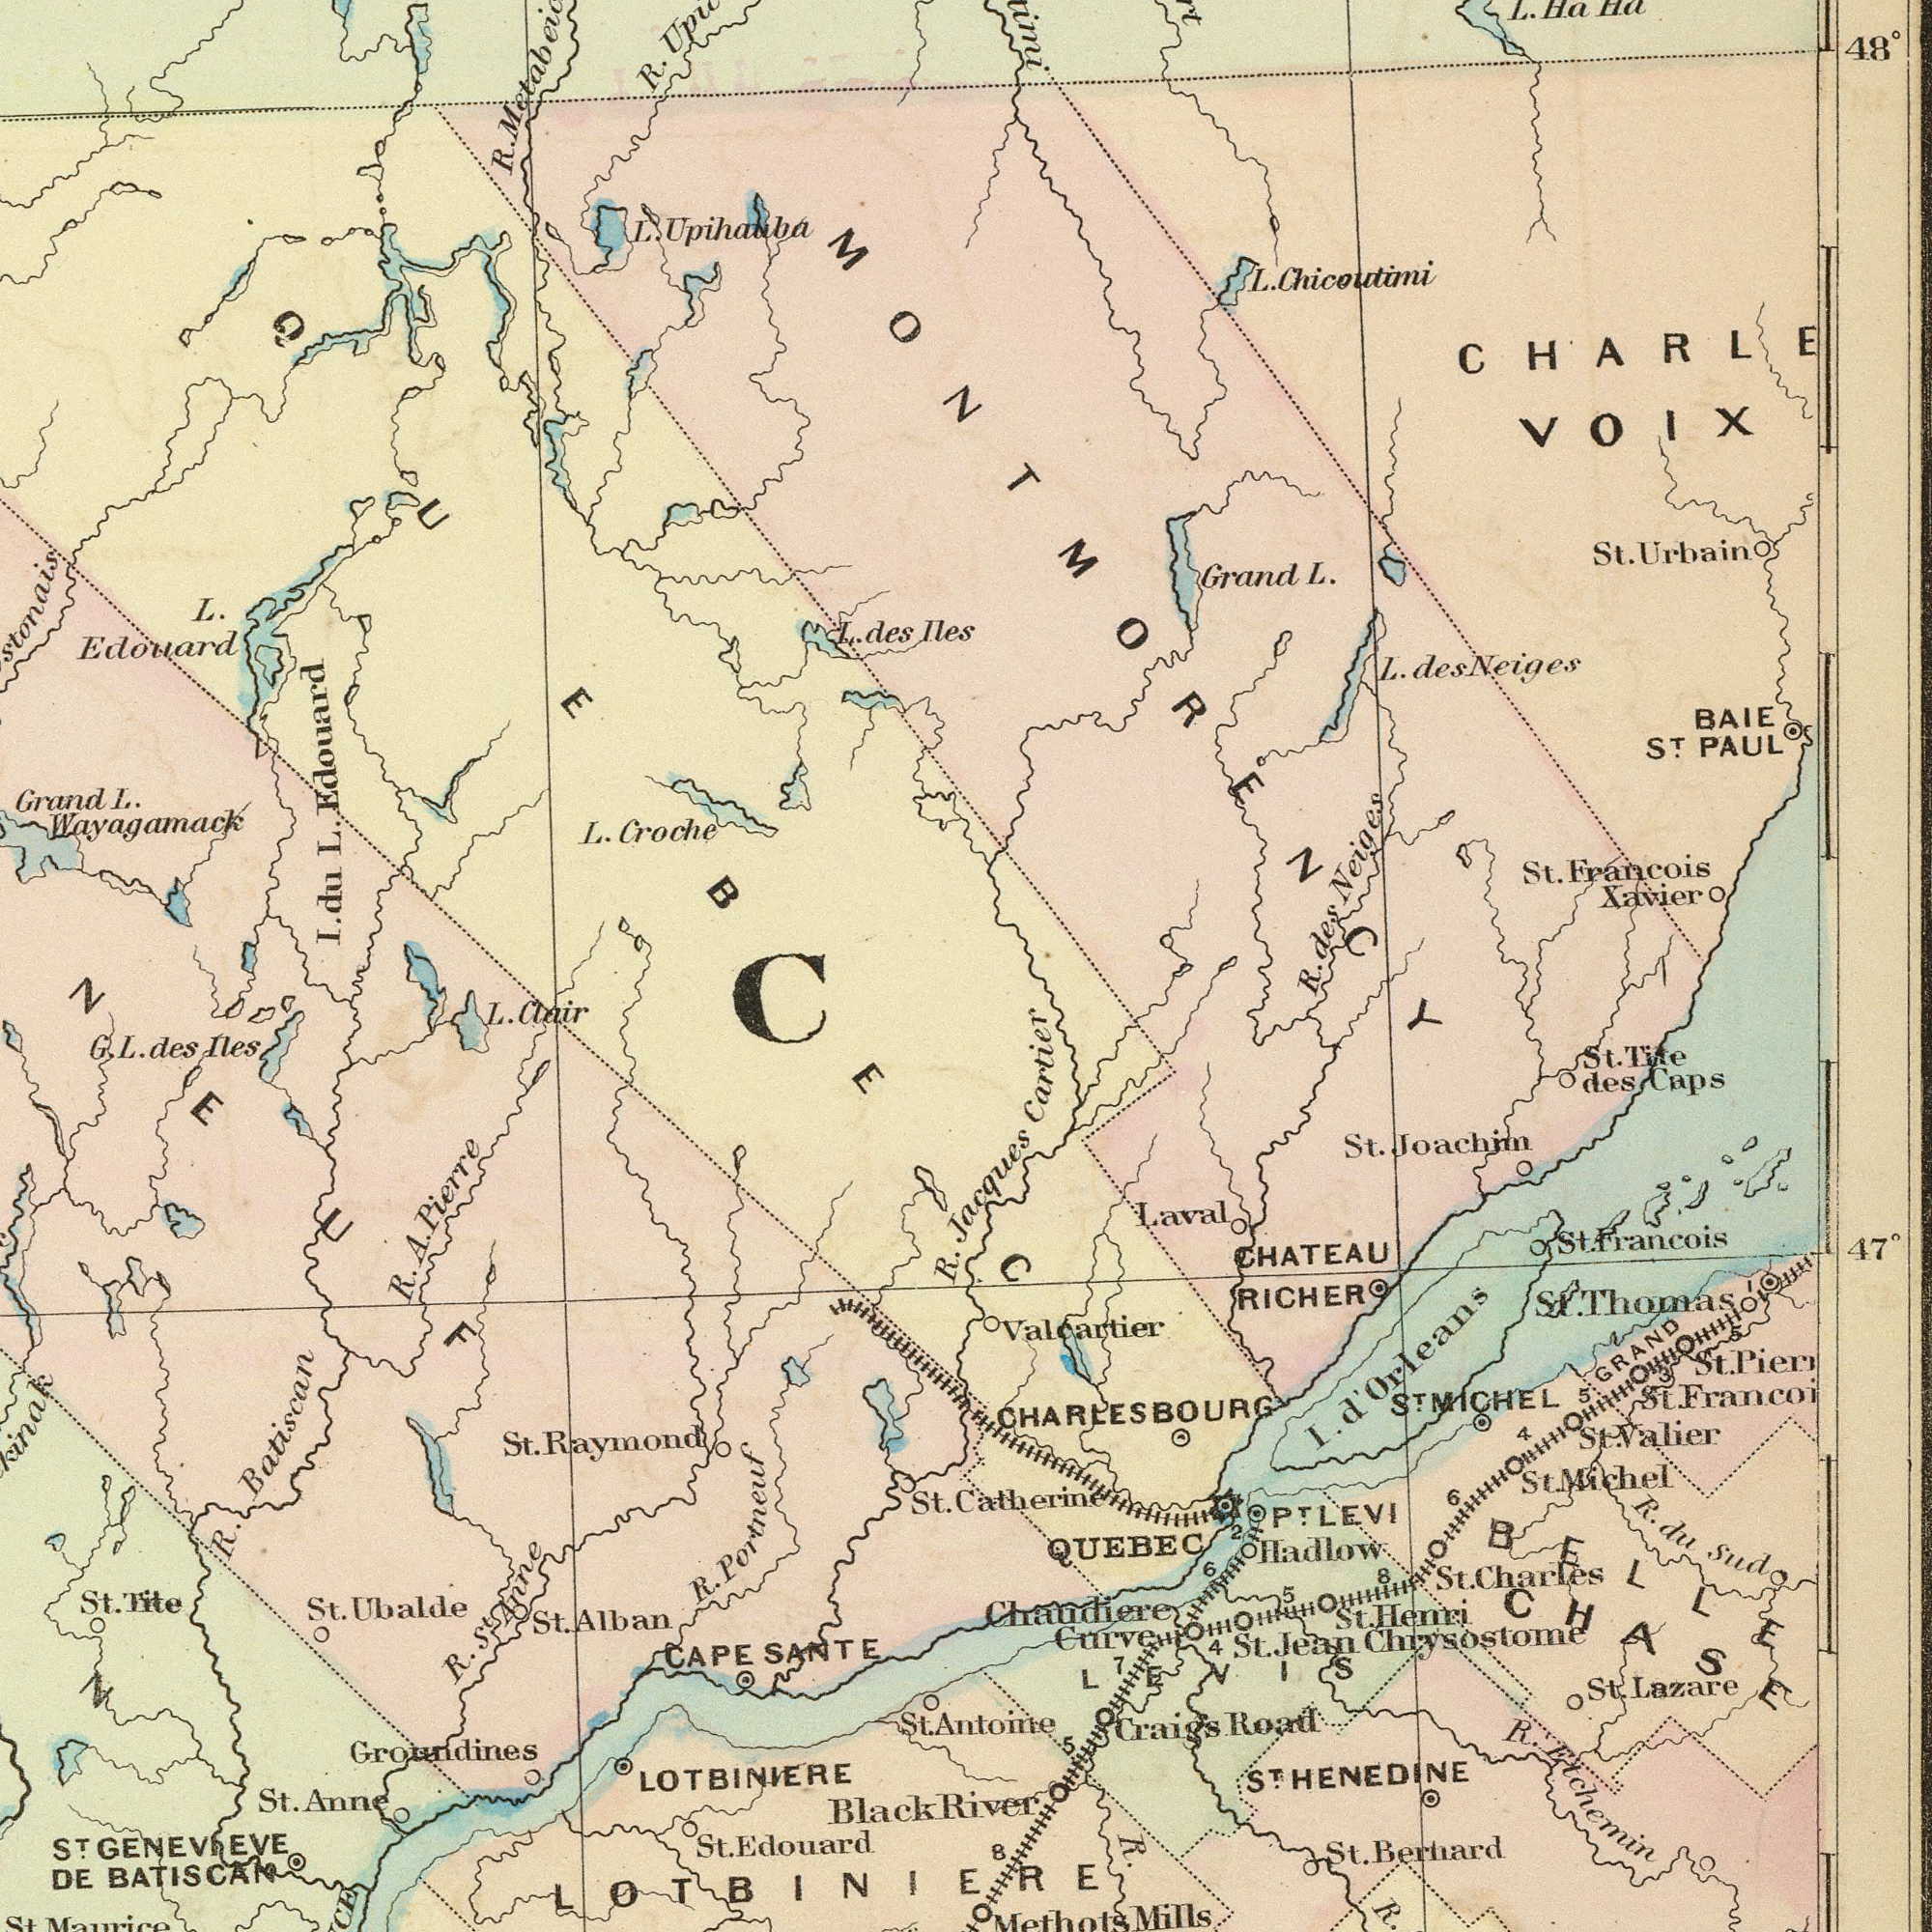What text is visible in the lower-left corner? Groundines St. Raymond R. Batiscan DE BATISCAN L. Clair Black R. A. Pierre R. R. Portneuf CAPE SANTE LOTBINIERE St. G. L. des Iles St. Anne St. Ubalde St. Tite N St. LOTBINIERE R. St. Anne ST GENEVIEVE St. Edouard St. Alban NEUF C What text appears in the top-right area of the image? St. Francois Xavier Grand L. 48° ST. BAIE PAUL des Neiges L. Chicoutini CHARLE VOIX St. Urbain L. des Neiges L. Ha Ha MONTMORENCY What text appears in the top-left area of the image? Wayagamack I. du L. Edouara R. Grand L. L. Edouard L. Croche L. des Ile. R. L. Upihauba QUEBEC What text appears in the bottom-right area of the image? R. RIver Jacques Cartier Antome Catherine St. Berhard CHATEAU RICHER St. valier Valcartier Hadlow STMICHEL St. Lazare R. St. Joachim St. Tile des Caps Chaudiere Mills R. Etchemin Laval st. Michel R. R.du Sud CHARLESBOURG QUEBEC St. Charles 47° I. d'Orleans St. Henri GRAND St. Francois 5 St Francoi PTLEVI St. Pier St. Jean Chrysostome 4 ST. St.Thomas BELLE CHASE 8 8 5 Curve LEVIS Craigs Road 4 R. 5 7 6 I 6 2 ST HENEDINE 